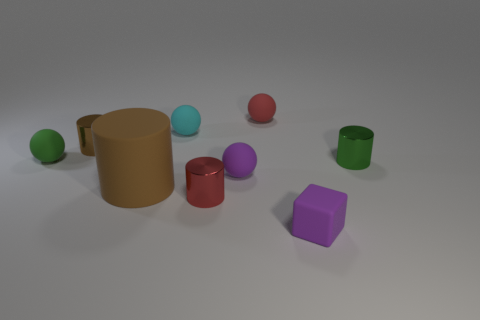How many brown cylinders must be subtracted to get 1 brown cylinders? 1 Add 1 red shiny cylinders. How many objects exist? 10 Subtract all purple matte spheres. How many spheres are left? 3 Subtract all purple cubes. How many brown cylinders are left? 2 Subtract all cubes. How many objects are left? 8 Subtract all green cylinders. How many cylinders are left? 3 Add 1 blue metallic spheres. How many blue metallic spheres exist? 1 Subtract 1 purple cubes. How many objects are left? 8 Subtract all purple cylinders. Subtract all purple balls. How many cylinders are left? 4 Subtract all large brown rubber cubes. Subtract all cylinders. How many objects are left? 5 